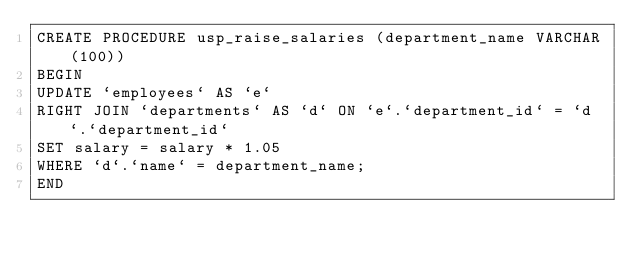<code> <loc_0><loc_0><loc_500><loc_500><_SQL_>CREATE PROCEDURE usp_raise_salaries (department_name VARCHAR(100))
BEGIN
UPDATE `employees` AS `e`
RIGHT JOIN `departments` AS `d` ON `e`.`department_id` = `d`.`department_id`
SET salary = salary * 1.05
WHERE `d`.`name` = department_name;
END
</code> 